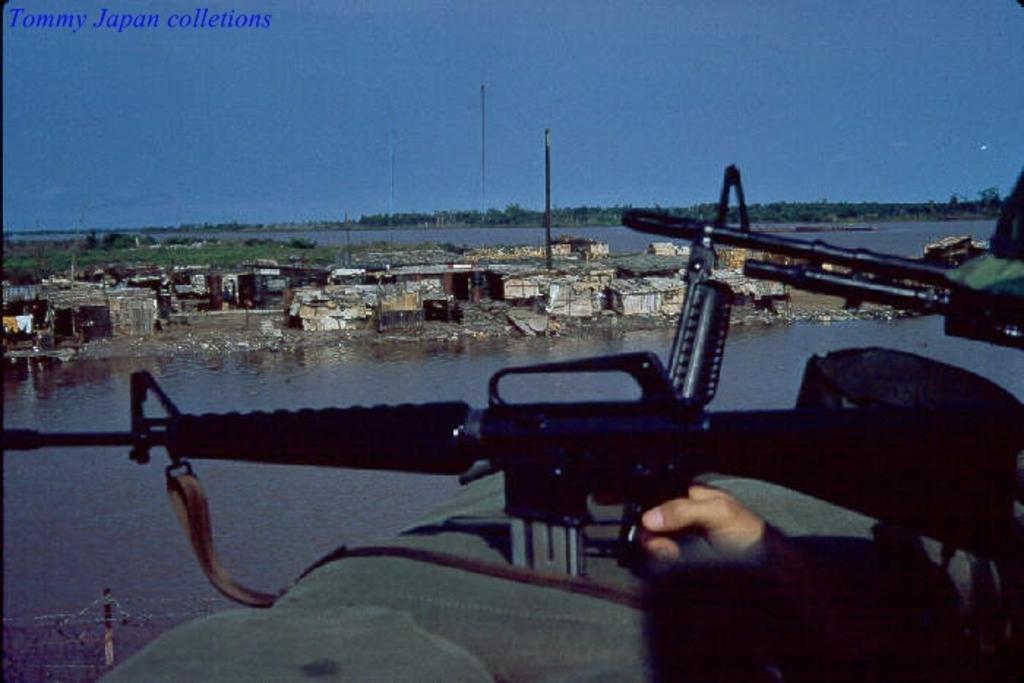In one or two sentences, can you explain what this image depicts? On the right side, I can see a person's hand holding a gun. In the background, I can see a river, few houses, poles and trees. At the top of the image I can see the sky. In the top left, I can see some text. 